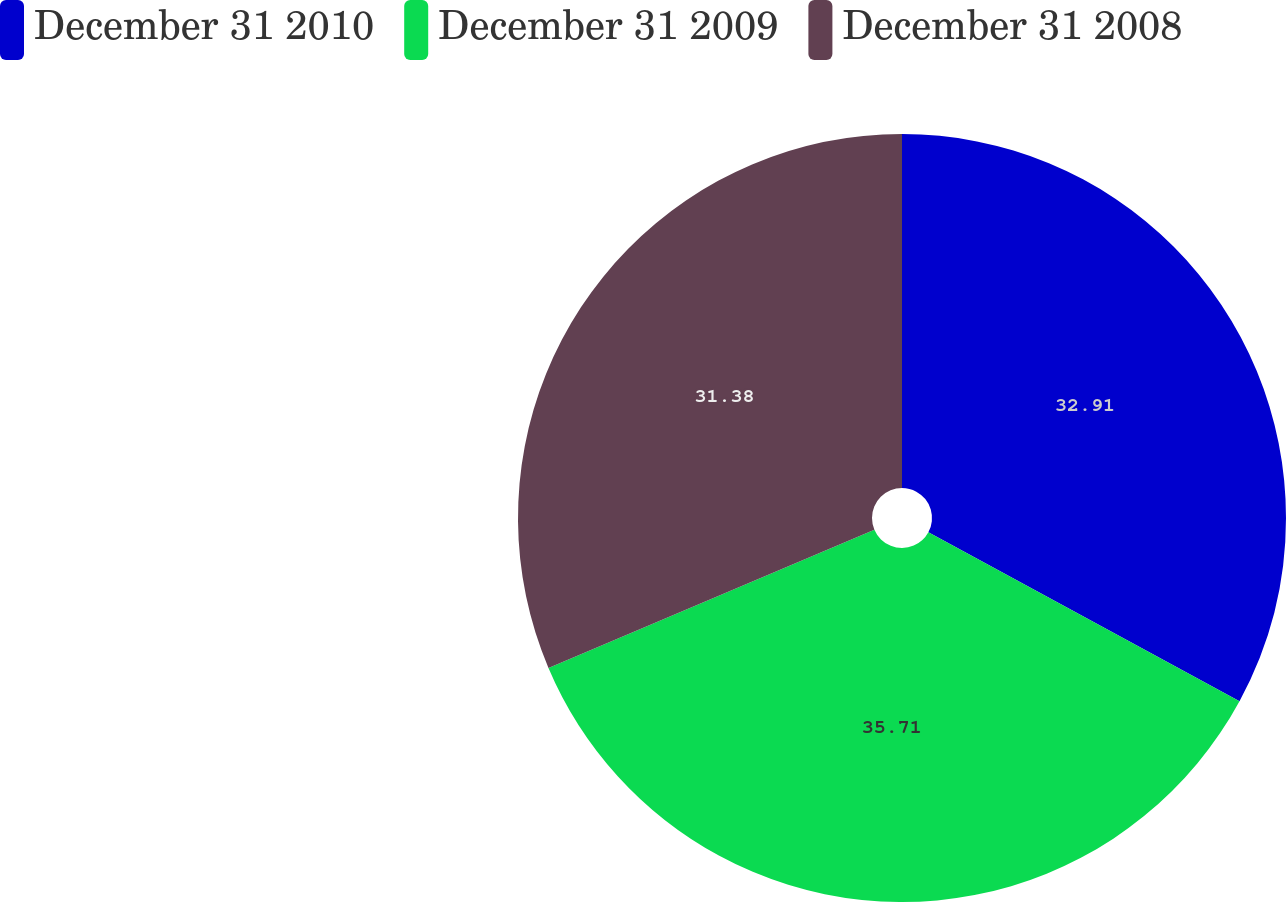Convert chart. <chart><loc_0><loc_0><loc_500><loc_500><pie_chart><fcel>December 31 2010<fcel>December 31 2009<fcel>December 31 2008<nl><fcel>32.91%<fcel>35.7%<fcel>31.38%<nl></chart> 